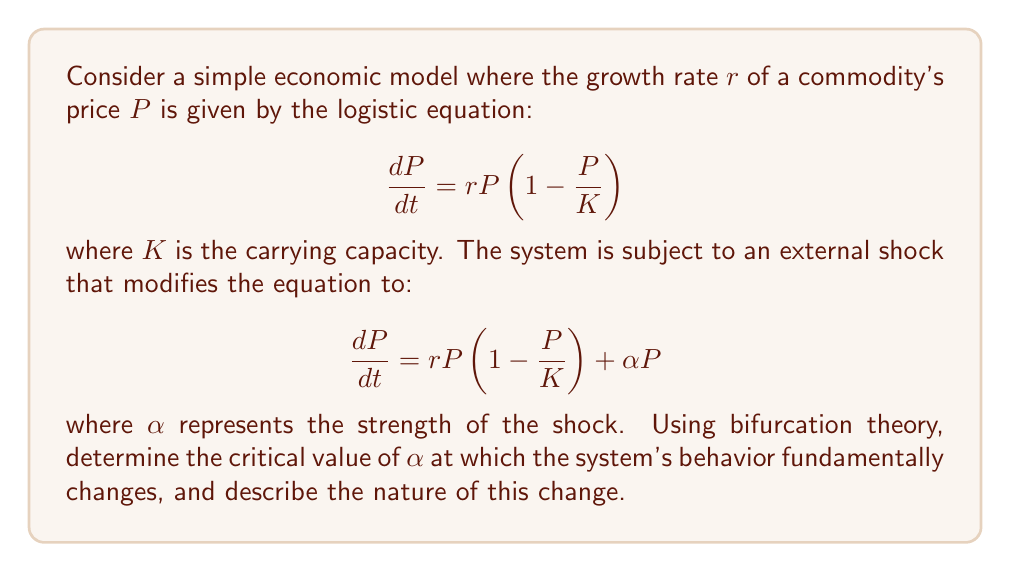Give your solution to this math problem. Let's approach this step-by-step:

1) First, we need to find the equilibrium points of the system. Set $\frac{dP}{dt} = 0$:

   $$rP(1-\frac{P}{K}) + \alpha P = 0$$

2) Factor out $P$:

   $$P(r(1-\frac{P}{K}) + \alpha) = 0$$

3) This gives us two equilibrium points:
   
   $P_1 = 0$ and $P_2 = K(1 + \frac{\alpha}{r})$

4) Now, we need to analyze the stability of these equilibrium points. We do this by finding the derivative of the right-hand side of the equation with respect to $P$:

   $$\frac{d}{dP}(rP(1-\frac{P}{K}) + \alpha P) = r(1-\frac{2P}{K}) + \alpha$$

5) At $P_1 = 0$, the stability is determined by:

   $$r + \alpha$$

   If this is positive, $P_1$ is unstable; if negative, it's stable.

6) At $P_2 = K(1 + \frac{\alpha}{r})$, the stability is determined by:

   $$r(1-\frac{2K(1 + \frac{\alpha}{r})}{K}) + \alpha = -r - \alpha$$

   If this is negative, $P_2$ is stable; if positive, it's unstable.

7) The bifurcation occurs when the stability of these points changes. This happens when:

   $$r + \alpha = 0$$
   $$\alpha = -r$$

8) At this critical value of $\alpha$, the two equilibrium points exchange stability. When $\alpha < -r$, $P_1$ is stable and $P_2$ is negative (and thus not meaningful in an economic context). When $\alpha > -r$, $P_1$ becomes unstable and $P_2$ becomes positive and stable.

This type of bifurcation is known as a transcritical bifurcation.
Answer: $\alpha_{critical} = -r$; Transcritical bifurcation 